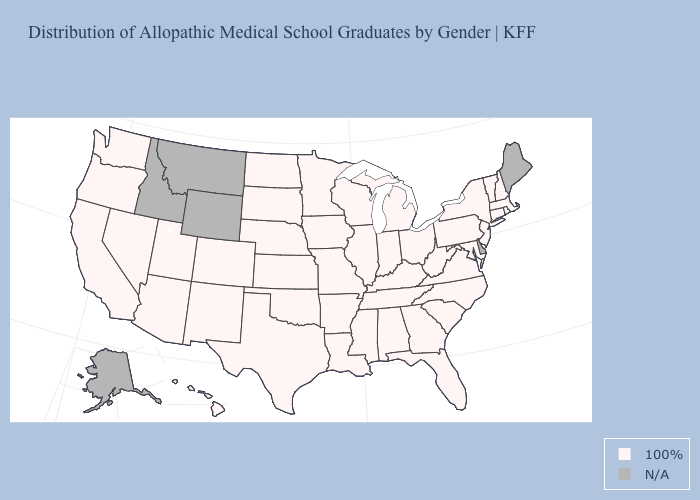Does the map have missing data?
Be succinct. Yes. What is the lowest value in states that border North Carolina?
Be succinct. 100%. What is the value of New York?
Be succinct. 100%. What is the highest value in states that border Indiana?
Write a very short answer. 100%. Which states have the lowest value in the West?
Be succinct. Arizona, California, Colorado, Hawaii, Nevada, New Mexico, Oregon, Utah, Washington. Which states have the lowest value in the South?
Be succinct. Alabama, Arkansas, Florida, Georgia, Kentucky, Louisiana, Maryland, Mississippi, North Carolina, Oklahoma, South Carolina, Tennessee, Texas, Virginia, West Virginia. Does the first symbol in the legend represent the smallest category?
Write a very short answer. Yes. What is the value of Nevada?
Quick response, please. 100%. Which states have the lowest value in the USA?
Be succinct. Alabama, Arizona, Arkansas, California, Colorado, Connecticut, Florida, Georgia, Hawaii, Illinois, Indiana, Iowa, Kansas, Kentucky, Louisiana, Maryland, Massachusetts, Michigan, Minnesota, Mississippi, Missouri, Nebraska, Nevada, New Hampshire, New Jersey, New Mexico, New York, North Carolina, North Dakota, Ohio, Oklahoma, Oregon, Pennsylvania, Rhode Island, South Carolina, South Dakota, Tennessee, Texas, Utah, Vermont, Virginia, Washington, West Virginia, Wisconsin. Among the states that border New York , which have the highest value?
Answer briefly. Connecticut, Massachusetts, New Jersey, Pennsylvania, Vermont. Does the map have missing data?
Keep it brief. Yes. 